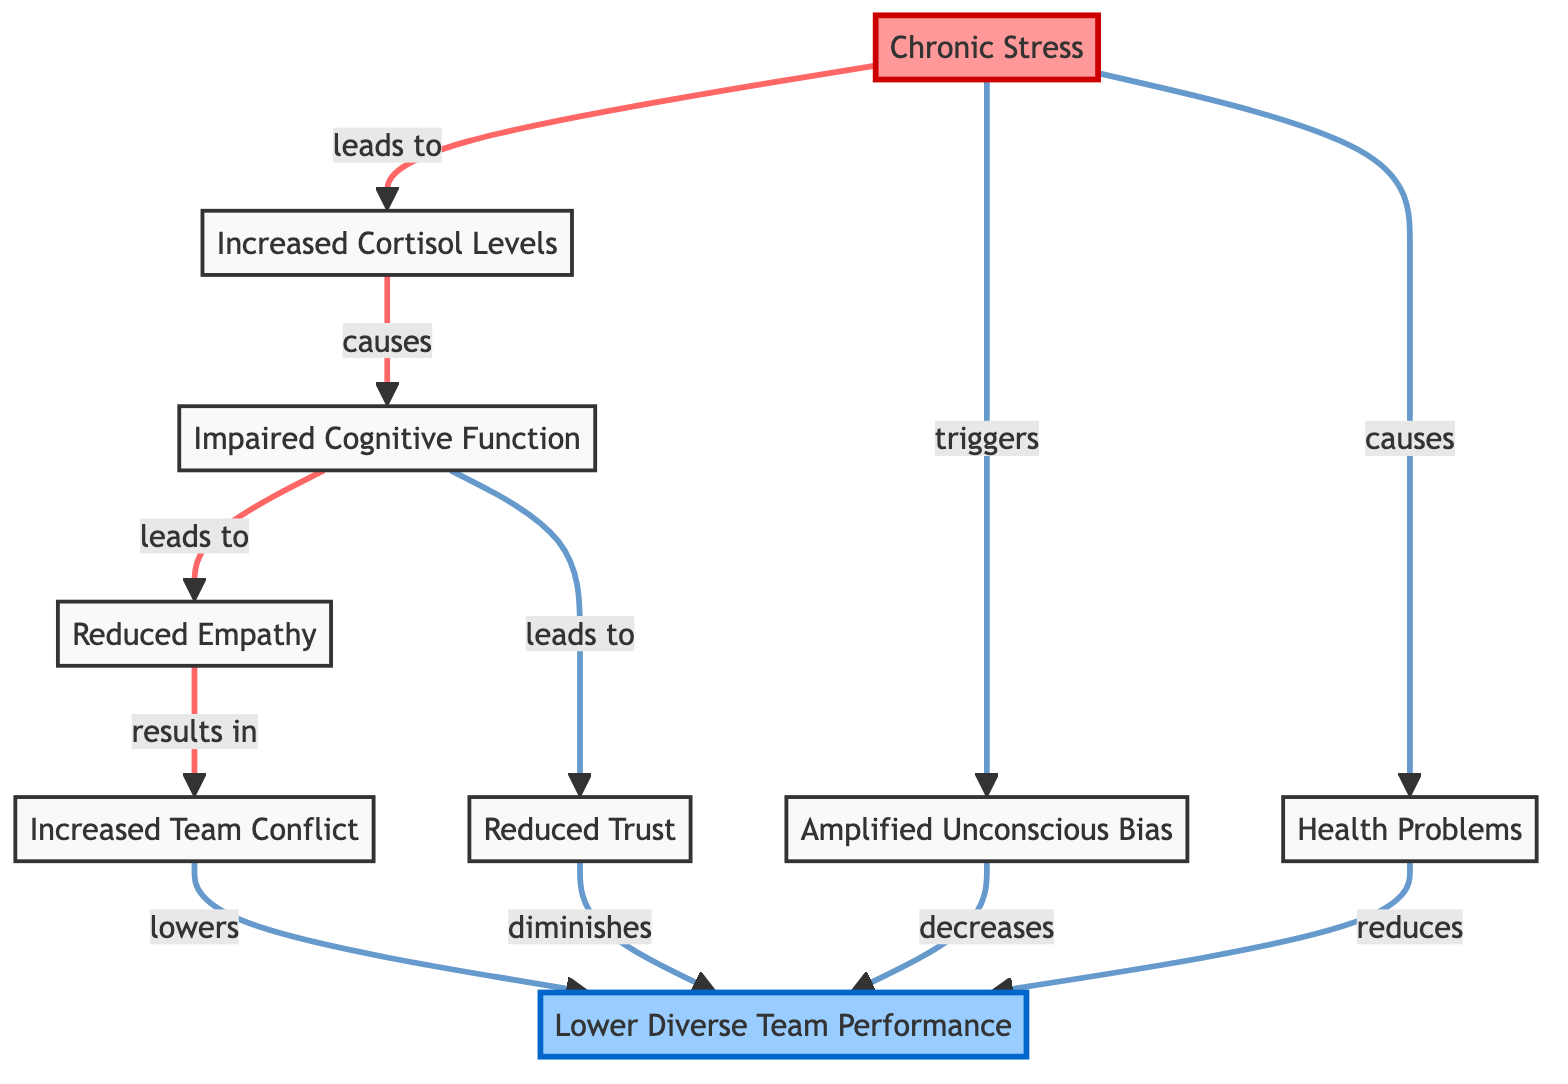What is the primary factor illustrated in the diagram? The diagram illustrates "Chronic Stress" as the primary factor affecting diverse teams and inclusion. This can be identified as it is the main node from which all other effects branch out.
Answer: Chronic Stress How many consequences of chronic stress are identified in the diagram? Counting the edges leading from "Chronic Stress," we see five primary consequences: Increased Cortisol Levels, bias amplification, health problems, cognitive function, and the resulting team conflict. This gives us a total of five unique consequences.
Answer: 5 What effect does reduced empathy have on team dynamics? The diagram indicates that reduced empathy leads to increased team conflict, which can be traced by following the arrows from "Reduced Empathy" to "Increased Team Conflict," clearly establishing this relationship.
Answer: Increased Team Conflict How does increased cortisol levels affect cognitive function? Increased Cortisol Levels lead to impaired cognitive function as per the direct connection illustrated in the diagram, showing that as cortisol levels rise, cognitive function becomes compromised.
Answer: Impaired Cognitive Function Which factor directly decreases diverse team performance according to the diagram? The diagram shows multiple arrows leading to "Lower Diverse Team Performance," specifically citing reduced empathy, bias amplification, health problems, and reduced trust as direct factors causing this decrease.
Answer: Reduced Empathy, Bias Amplification, Health Problems, Reduced Trust What physiological response is triggered by chronic stress? The diagram indicates that chronic stress triggers "Bias Amplification," which reflects a physiological response to stress that increases unconscious bias, represented by a direct arrow pointing from "Chronic Stress" to "Bias Amplification."
Answer: Bias Amplification What is the final outcome of impaired cognitive function illustrated in the diagram? Following the arrows from "Impaired Cognitive Function," the final outcome indicated is "Lower Diverse Team Performance," making it clear that cognitive impairment ultimately affects team performance.
Answer: Lower Diverse Team Performance How are health problems related to diverse team performance? Health problems have a direct relationship with diverse team performance, as indicated in the diagram where health problems reduce performance, demonstrated by the directional arrow leading to "Lower Diverse Team Performance."
Answer: Reduces Diverse Team Performance Which node highlights the psychological impact of chronic stress? The node marked "Reduced Trust" highlights a psychological impact stemming from chronic stress, showing a decrease in trust due to impaired cognitive function via the arrows illustrated in the diagram.
Answer: Reduced Trust 